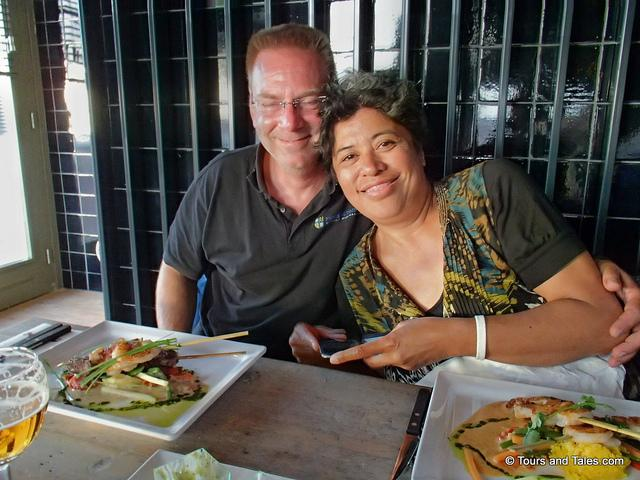How is the man's sight without assistance? poor 